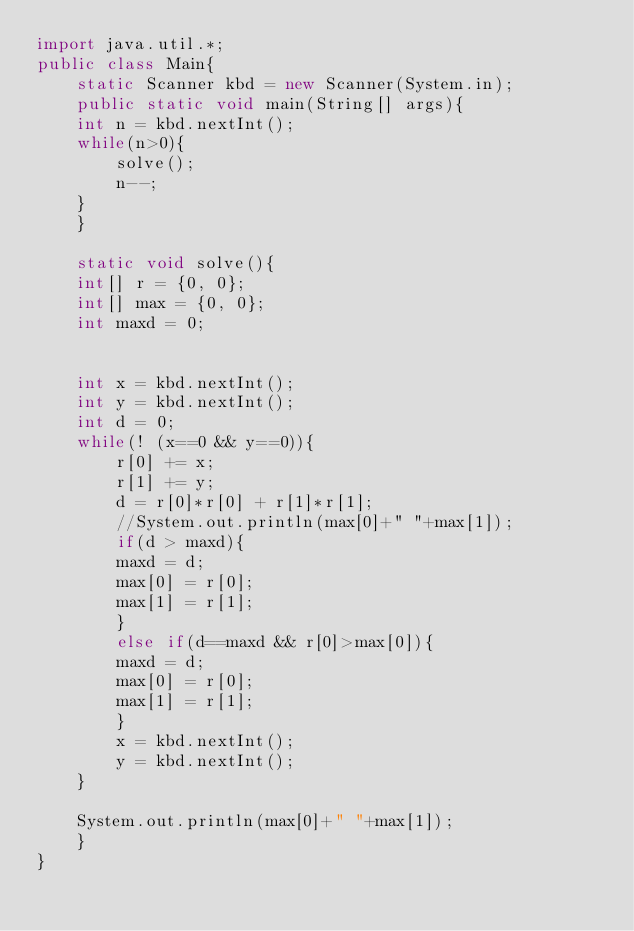<code> <loc_0><loc_0><loc_500><loc_500><_Java_>import java.util.*;
public class Main{
    static Scanner kbd = new Scanner(System.in);
    public static void main(String[] args){
	int n = kbd.nextInt();
	while(n>0){
	    solve();
	    n--;
	}
    }

    static void solve(){
	int[] r = {0, 0};
	int[] max = {0, 0};
	int maxd = 0;


	int x = kbd.nextInt();
	int y = kbd.nextInt();
	int d = 0;
	while(! (x==0 && y==0)){
	    r[0] += x;
	    r[1] += y;
	    d = r[0]*r[0] + r[1]*r[1];
	    //System.out.println(max[0]+" "+max[1]);
	    if(d > maxd){
		maxd = d;
		max[0] = r[0];
		max[1] = r[1];
	    }
	    else if(d==maxd && r[0]>max[0]){
		maxd = d;
		max[0] = r[0];
		max[1] = r[1];
	    }
	    x = kbd.nextInt();
	    y = kbd.nextInt();
	}

	System.out.println(max[0]+" "+max[1]);
    }
}</code> 